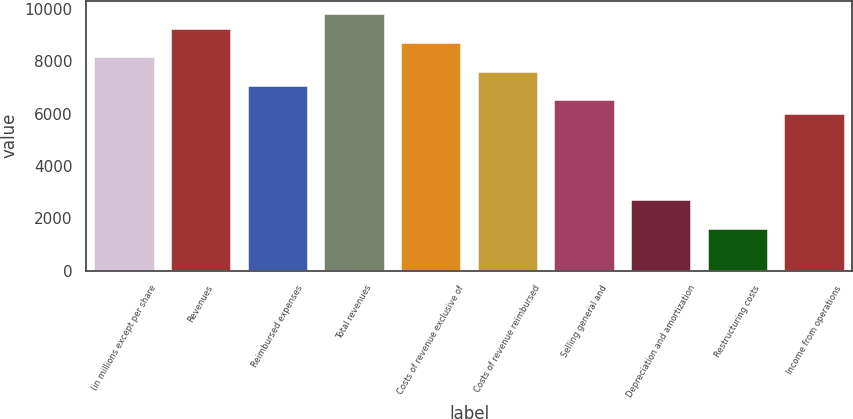Convert chart. <chart><loc_0><loc_0><loc_500><loc_500><bar_chart><fcel>(in millions except per share<fcel>Revenues<fcel>Reimbursed expenses<fcel>Total revenues<fcel>Costs of revenue exclusive of<fcel>Costs of revenue reimbursed<fcel>Selling general and<fcel>Depreciation and amortization<fcel>Restructuring costs<fcel>Income from operations<nl><fcel>8188.67<fcel>9280.13<fcel>7097.21<fcel>9825.86<fcel>8734.4<fcel>7642.94<fcel>6551.48<fcel>2731.37<fcel>1639.91<fcel>6005.75<nl></chart> 